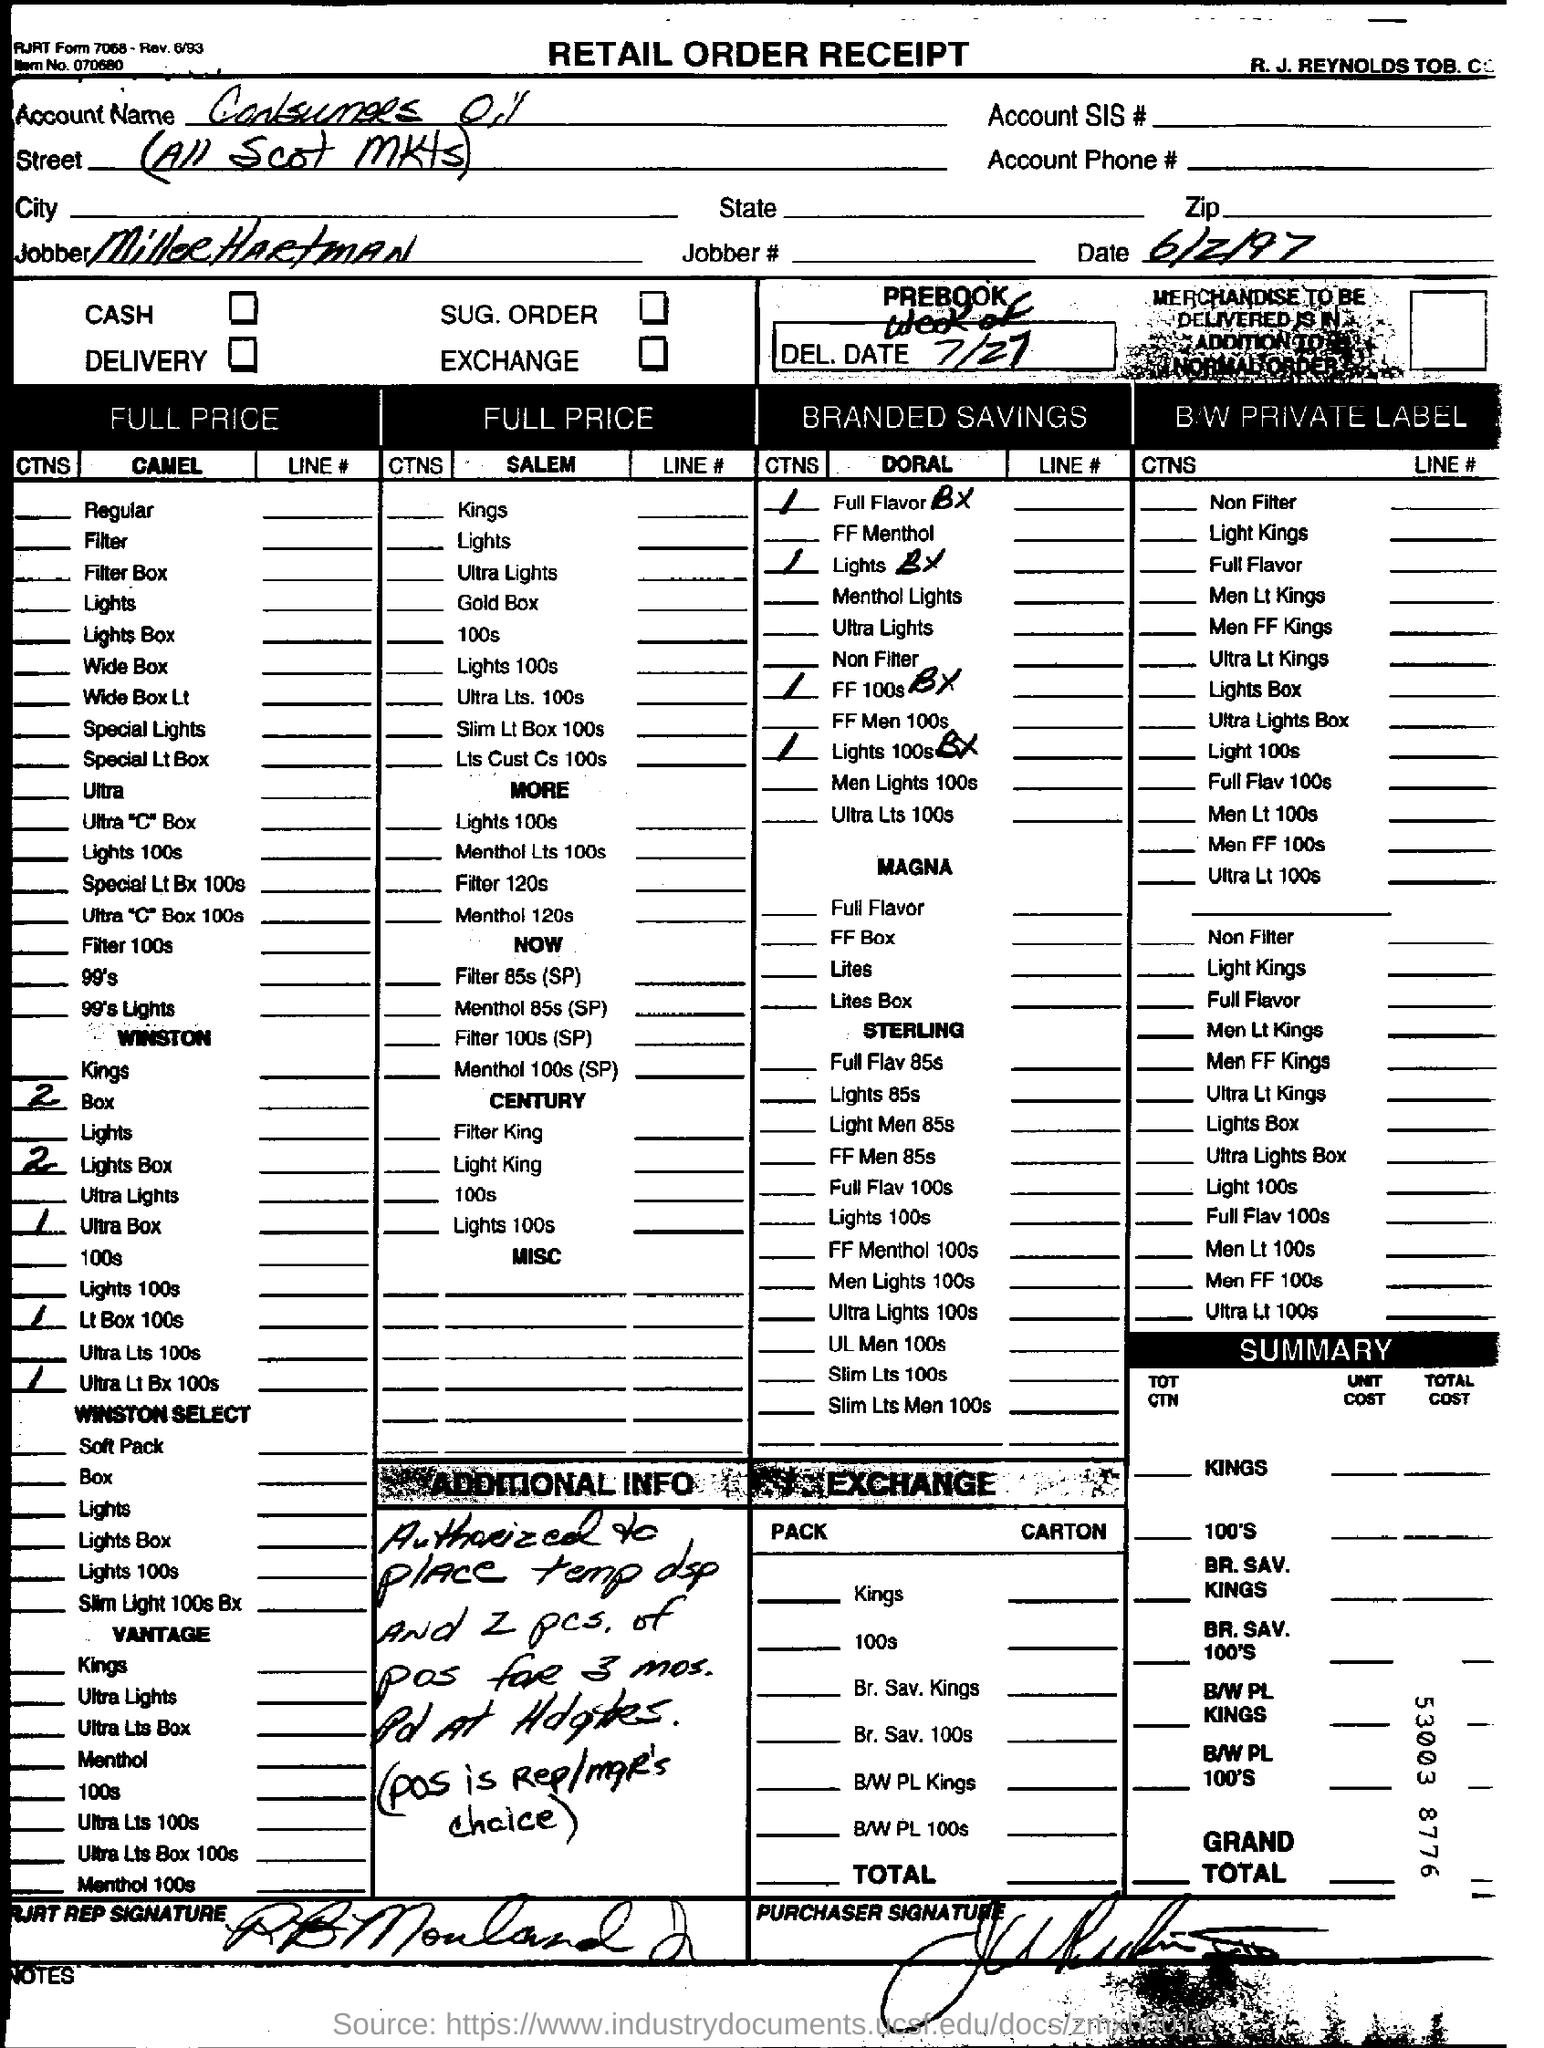What is the date on the document?
Ensure brevity in your answer.  6/2/97. Who is the Jobber?
Your answer should be compact. Miller Hartman. 